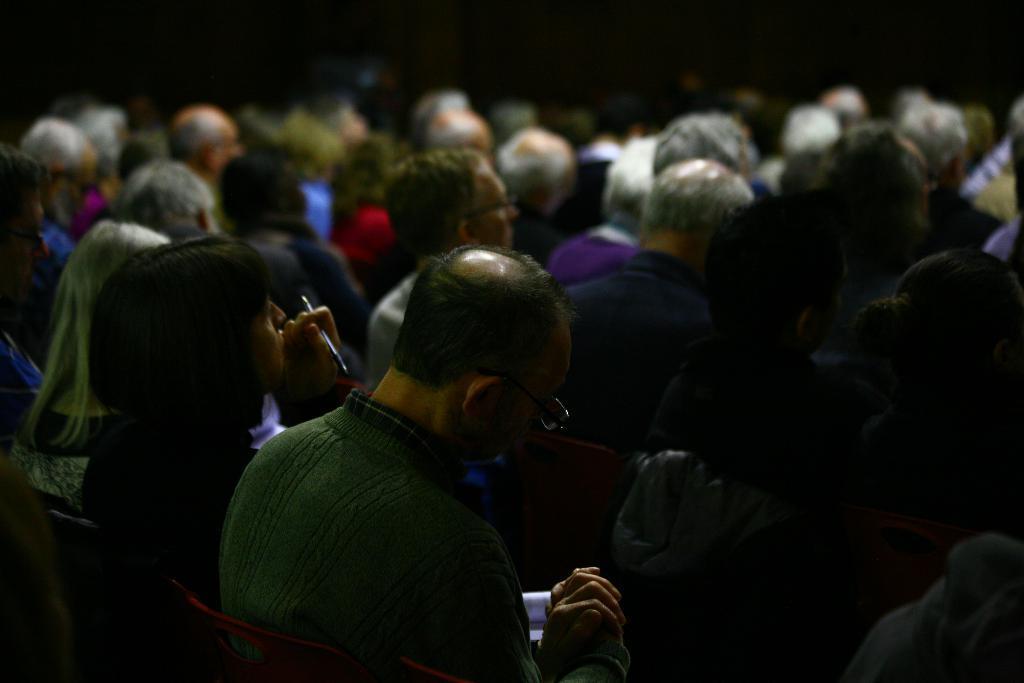Describe this image in one or two sentences. In this image there are few persons sitting on the chair. Left side there is a person holding a pen in his hand. Beside him there is a person wearing spectacles. Before him there is a person sitting on the chair which is having a cloth on it. 